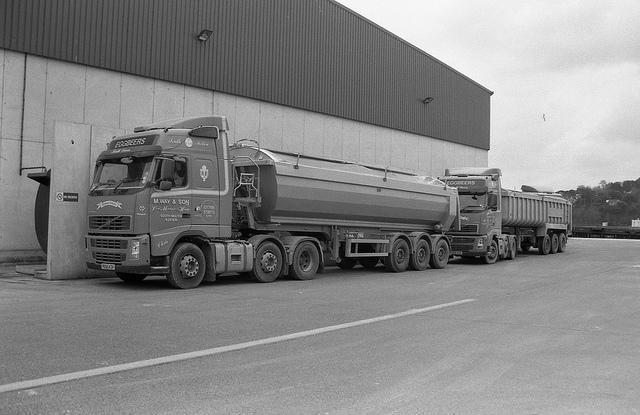How many trucks are outside?
Give a very brief answer. 2. How many wheels are visible?
Give a very brief answer. 12. How many trucks are in the picture?
Give a very brief answer. 2. How many sinks are visible?
Give a very brief answer. 0. 